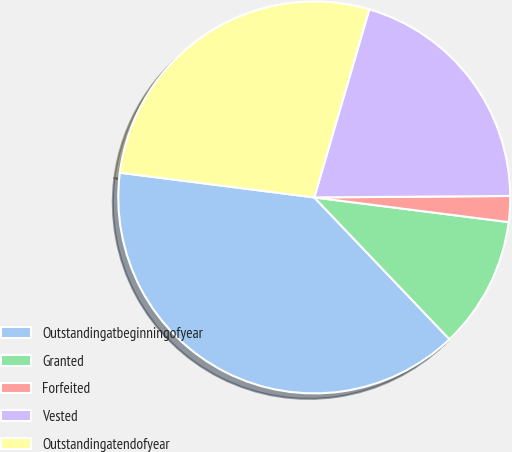Convert chart. <chart><loc_0><loc_0><loc_500><loc_500><pie_chart><fcel>Outstandingatbeginningofyear<fcel>Granted<fcel>Forfeited<fcel>Vested<fcel>Outstandingatendofyear<nl><fcel>39.13%<fcel>10.87%<fcel>2.13%<fcel>20.35%<fcel>27.52%<nl></chart> 